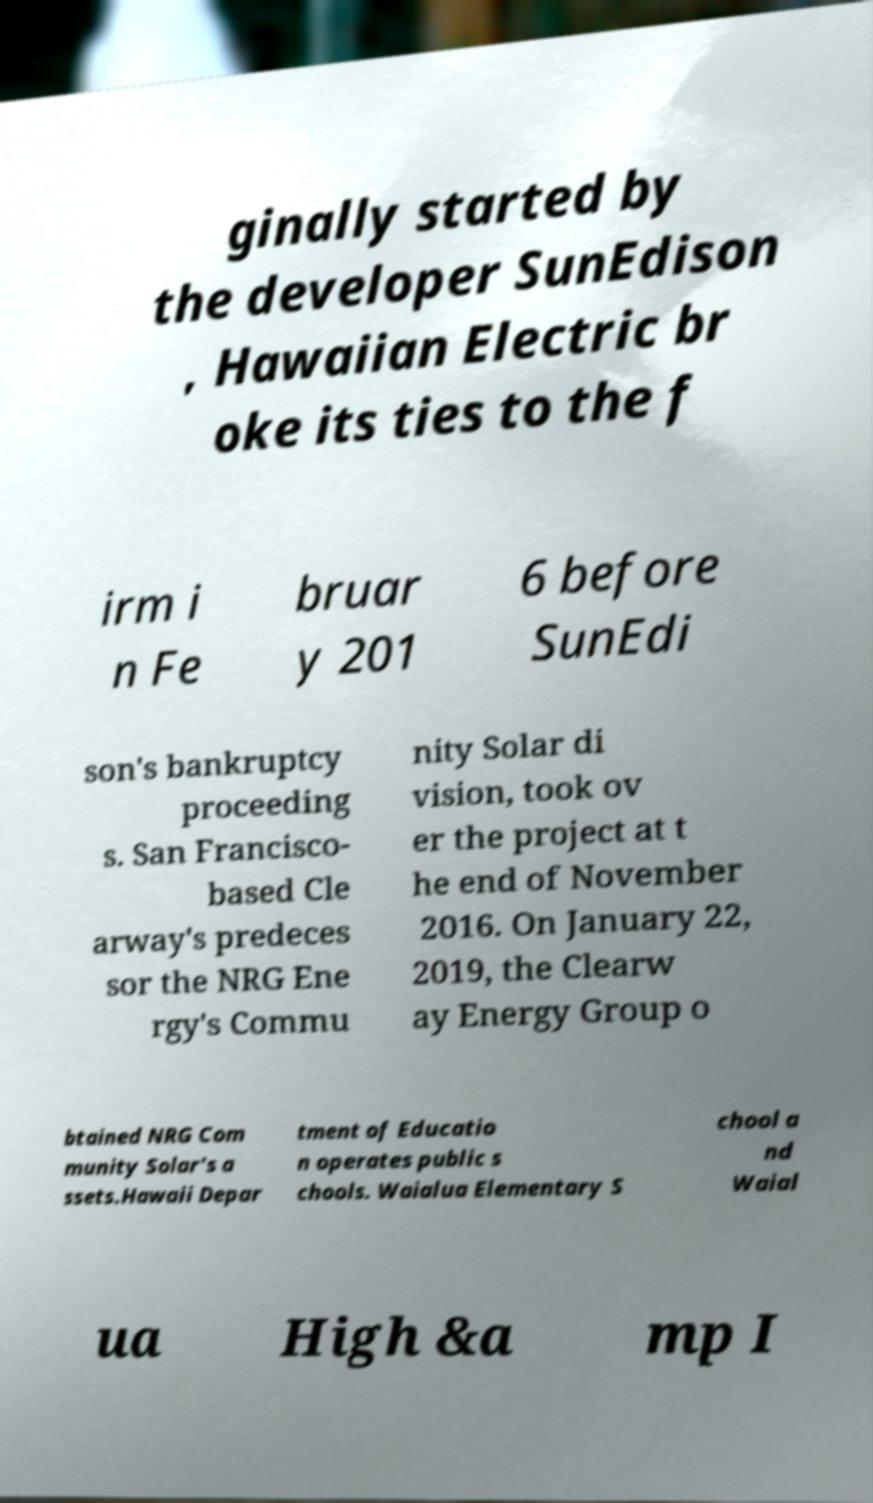Can you read and provide the text displayed in the image?This photo seems to have some interesting text. Can you extract and type it out for me? ginally started by the developer SunEdison , Hawaiian Electric br oke its ties to the f irm i n Fe bruar y 201 6 before SunEdi son's bankruptcy proceeding s. San Francisco- based Cle arway's predeces sor the NRG Ene rgy's Commu nity Solar di vision, took ov er the project at t he end of November 2016. On January 22, 2019, the Clearw ay Energy Group o btained NRG Com munity Solar's a ssets.Hawaii Depar tment of Educatio n operates public s chools. Waialua Elementary S chool a nd Waial ua High &a mp I 